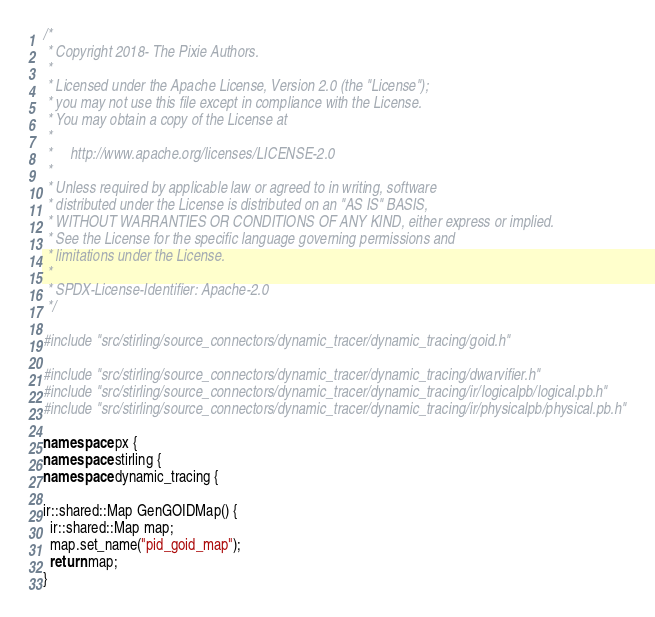Convert code to text. <code><loc_0><loc_0><loc_500><loc_500><_C++_>/*
 * Copyright 2018- The Pixie Authors.
 *
 * Licensed under the Apache License, Version 2.0 (the "License");
 * you may not use this file except in compliance with the License.
 * You may obtain a copy of the License at
 *
 *     http://www.apache.org/licenses/LICENSE-2.0
 *
 * Unless required by applicable law or agreed to in writing, software
 * distributed under the License is distributed on an "AS IS" BASIS,
 * WITHOUT WARRANTIES OR CONDITIONS OF ANY KIND, either express or implied.
 * See the License for the specific language governing permissions and
 * limitations under the License.
 *
 * SPDX-License-Identifier: Apache-2.0
 */

#include "src/stirling/source_connectors/dynamic_tracer/dynamic_tracing/goid.h"

#include "src/stirling/source_connectors/dynamic_tracer/dynamic_tracing/dwarvifier.h"
#include "src/stirling/source_connectors/dynamic_tracer/dynamic_tracing/ir/logicalpb/logical.pb.h"
#include "src/stirling/source_connectors/dynamic_tracer/dynamic_tracing/ir/physicalpb/physical.pb.h"

namespace px {
namespace stirling {
namespace dynamic_tracing {

ir::shared::Map GenGOIDMap() {
  ir::shared::Map map;
  map.set_name("pid_goid_map");
  return map;
}
</code> 